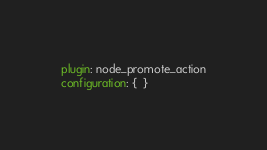<code> <loc_0><loc_0><loc_500><loc_500><_YAML_>plugin: node_promote_action
configuration: {  }
</code> 